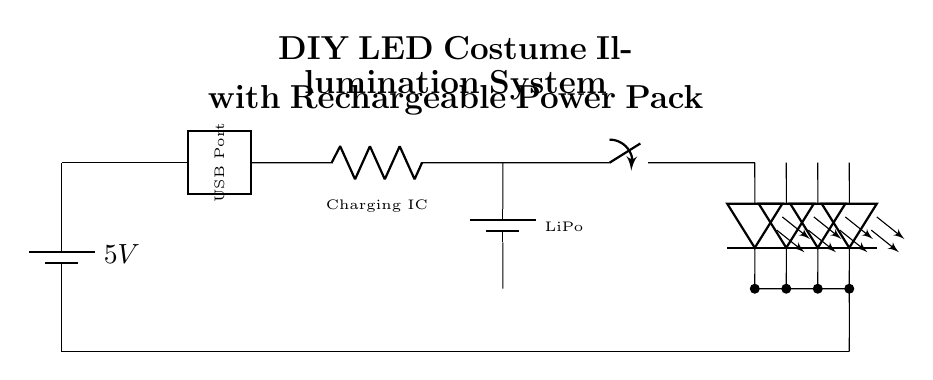what is the voltage of the battery? The circuit shows a battery labeled with a voltage of 5V, indicating that it provides a potential difference of 5 volts.
Answer: 5V what type of battery is used for charging? The diagram includes a rechargeable battery labeled as a LiPo battery, which is commonly used in DIY projects due to its efficiency and lightweight characteristics.
Answer: LiPo how many LEDs are in the circuit? The circuit diagram displays a total of four LEDs connected in parallel to the circuit, identifiable by their distinct symbols representing light-emitting diodes.
Answer: 4 what component is used for charging the battery? The circuit features a component labeled as the Charging IC, which is responsible for managing the charging process of the LiPo battery when energy is supplied through the USB port.
Answer: Charging IC what is the purpose of the switch in this circuit? The switch is used to control the flow of current to the LED array, allowing the user to turn the LEDs on or off as desired, essentially functioning as an operator-controlled gate in the circuit.
Answer: To control current what voltage is supplied to the LED array? The voltage supplied to the LED array comes from the LiPo battery, which is connected to the LEDs after the switch. In this setup, it’s expected to be around 3.7V (the nominal voltage of a LiPo battery).
Answer: Approximately 3.7V can this circuit be charged using a USB port? Yes, the circuit diagram includes a connection to a USB port, which allows the battery to be recharged through a standard USB interface, indicating it is compatible with common charging methods.
Answer: Yes 